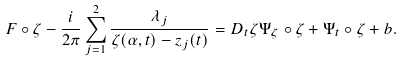<formula> <loc_0><loc_0><loc_500><loc_500>F \circ \zeta - \frac { i } { 2 \pi } \sum _ { j = 1 } ^ { 2 } \frac { \lambda _ { j } } { \zeta ( \alpha , t ) - z _ { j } ( t ) } = D _ { t } \zeta \Psi _ { \zeta } \circ \zeta + \Psi _ { t } \circ \zeta + b .</formula> 